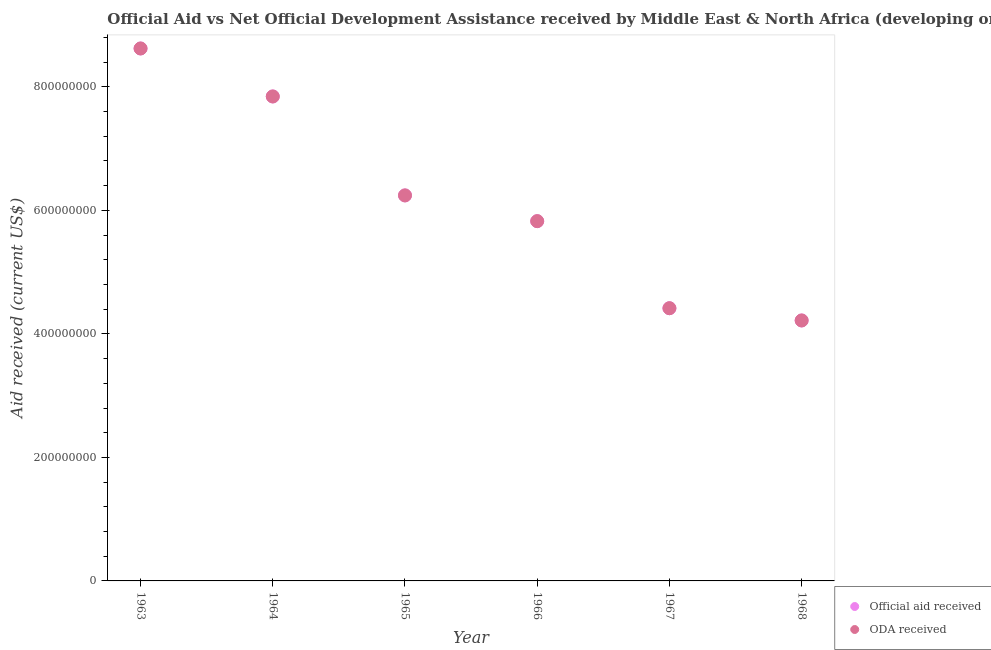How many different coloured dotlines are there?
Give a very brief answer. 2. What is the official aid received in 1964?
Make the answer very short. 7.84e+08. Across all years, what is the maximum oda received?
Offer a terse response. 8.62e+08. Across all years, what is the minimum oda received?
Make the answer very short. 4.22e+08. In which year was the oda received minimum?
Your response must be concise. 1968. What is the total oda received in the graph?
Offer a terse response. 3.72e+09. What is the difference between the oda received in 1965 and that in 1968?
Give a very brief answer. 2.02e+08. What is the difference between the official aid received in 1966 and the oda received in 1965?
Offer a very short reply. -4.17e+07. What is the average official aid received per year?
Give a very brief answer. 6.19e+08. What is the ratio of the official aid received in 1963 to that in 1964?
Keep it short and to the point. 1.1. Is the official aid received in 1966 less than that in 1967?
Give a very brief answer. No. What is the difference between the highest and the second highest official aid received?
Your answer should be very brief. 7.77e+07. What is the difference between the highest and the lowest official aid received?
Keep it short and to the point. 4.40e+08. How many years are there in the graph?
Offer a very short reply. 6. What is the difference between two consecutive major ticks on the Y-axis?
Provide a succinct answer. 2.00e+08. Are the values on the major ticks of Y-axis written in scientific E-notation?
Give a very brief answer. No. Does the graph contain any zero values?
Make the answer very short. No. How are the legend labels stacked?
Offer a terse response. Vertical. What is the title of the graph?
Provide a short and direct response. Official Aid vs Net Official Development Assistance received by Middle East & North Africa (developing only) . Does "Passenger Transport Items" appear as one of the legend labels in the graph?
Keep it short and to the point. No. What is the label or title of the Y-axis?
Your response must be concise. Aid received (current US$). What is the Aid received (current US$) of Official aid received in 1963?
Ensure brevity in your answer.  8.62e+08. What is the Aid received (current US$) in ODA received in 1963?
Ensure brevity in your answer.  8.62e+08. What is the Aid received (current US$) in Official aid received in 1964?
Your answer should be compact. 7.84e+08. What is the Aid received (current US$) of ODA received in 1964?
Make the answer very short. 7.84e+08. What is the Aid received (current US$) in Official aid received in 1965?
Offer a very short reply. 6.24e+08. What is the Aid received (current US$) in ODA received in 1965?
Give a very brief answer. 6.24e+08. What is the Aid received (current US$) in Official aid received in 1966?
Your response must be concise. 5.83e+08. What is the Aid received (current US$) in ODA received in 1966?
Provide a short and direct response. 5.83e+08. What is the Aid received (current US$) of Official aid received in 1967?
Keep it short and to the point. 4.42e+08. What is the Aid received (current US$) in ODA received in 1967?
Make the answer very short. 4.42e+08. What is the Aid received (current US$) in Official aid received in 1968?
Your answer should be compact. 4.22e+08. What is the Aid received (current US$) in ODA received in 1968?
Offer a terse response. 4.22e+08. Across all years, what is the maximum Aid received (current US$) of Official aid received?
Your answer should be compact. 8.62e+08. Across all years, what is the maximum Aid received (current US$) in ODA received?
Provide a short and direct response. 8.62e+08. Across all years, what is the minimum Aid received (current US$) in Official aid received?
Offer a terse response. 4.22e+08. Across all years, what is the minimum Aid received (current US$) in ODA received?
Offer a very short reply. 4.22e+08. What is the total Aid received (current US$) in Official aid received in the graph?
Ensure brevity in your answer.  3.72e+09. What is the total Aid received (current US$) of ODA received in the graph?
Keep it short and to the point. 3.72e+09. What is the difference between the Aid received (current US$) of Official aid received in 1963 and that in 1964?
Make the answer very short. 7.77e+07. What is the difference between the Aid received (current US$) of ODA received in 1963 and that in 1964?
Ensure brevity in your answer.  7.77e+07. What is the difference between the Aid received (current US$) of Official aid received in 1963 and that in 1965?
Offer a very short reply. 2.38e+08. What is the difference between the Aid received (current US$) in ODA received in 1963 and that in 1965?
Offer a very short reply. 2.38e+08. What is the difference between the Aid received (current US$) in Official aid received in 1963 and that in 1966?
Ensure brevity in your answer.  2.80e+08. What is the difference between the Aid received (current US$) of ODA received in 1963 and that in 1966?
Your answer should be very brief. 2.80e+08. What is the difference between the Aid received (current US$) of Official aid received in 1963 and that in 1967?
Provide a succinct answer. 4.21e+08. What is the difference between the Aid received (current US$) in ODA received in 1963 and that in 1967?
Provide a short and direct response. 4.21e+08. What is the difference between the Aid received (current US$) of Official aid received in 1963 and that in 1968?
Give a very brief answer. 4.40e+08. What is the difference between the Aid received (current US$) in ODA received in 1963 and that in 1968?
Keep it short and to the point. 4.40e+08. What is the difference between the Aid received (current US$) of Official aid received in 1964 and that in 1965?
Your answer should be very brief. 1.60e+08. What is the difference between the Aid received (current US$) of ODA received in 1964 and that in 1965?
Your answer should be very brief. 1.60e+08. What is the difference between the Aid received (current US$) of Official aid received in 1964 and that in 1966?
Your answer should be very brief. 2.02e+08. What is the difference between the Aid received (current US$) of ODA received in 1964 and that in 1966?
Offer a very short reply. 2.02e+08. What is the difference between the Aid received (current US$) of Official aid received in 1964 and that in 1967?
Your answer should be compact. 3.43e+08. What is the difference between the Aid received (current US$) of ODA received in 1964 and that in 1967?
Your answer should be very brief. 3.43e+08. What is the difference between the Aid received (current US$) of Official aid received in 1964 and that in 1968?
Offer a very short reply. 3.63e+08. What is the difference between the Aid received (current US$) of ODA received in 1964 and that in 1968?
Your answer should be compact. 3.63e+08. What is the difference between the Aid received (current US$) of Official aid received in 1965 and that in 1966?
Offer a terse response. 4.17e+07. What is the difference between the Aid received (current US$) of ODA received in 1965 and that in 1966?
Provide a short and direct response. 4.17e+07. What is the difference between the Aid received (current US$) in Official aid received in 1965 and that in 1967?
Your answer should be compact. 1.83e+08. What is the difference between the Aid received (current US$) of ODA received in 1965 and that in 1967?
Offer a terse response. 1.83e+08. What is the difference between the Aid received (current US$) in Official aid received in 1965 and that in 1968?
Your response must be concise. 2.02e+08. What is the difference between the Aid received (current US$) of ODA received in 1965 and that in 1968?
Provide a short and direct response. 2.02e+08. What is the difference between the Aid received (current US$) in Official aid received in 1966 and that in 1967?
Provide a succinct answer. 1.41e+08. What is the difference between the Aid received (current US$) of ODA received in 1966 and that in 1967?
Offer a terse response. 1.41e+08. What is the difference between the Aid received (current US$) in Official aid received in 1966 and that in 1968?
Offer a terse response. 1.61e+08. What is the difference between the Aid received (current US$) of ODA received in 1966 and that in 1968?
Your answer should be very brief. 1.61e+08. What is the difference between the Aid received (current US$) in Official aid received in 1967 and that in 1968?
Provide a succinct answer. 1.98e+07. What is the difference between the Aid received (current US$) in ODA received in 1967 and that in 1968?
Provide a short and direct response. 1.98e+07. What is the difference between the Aid received (current US$) of Official aid received in 1963 and the Aid received (current US$) of ODA received in 1964?
Offer a terse response. 7.77e+07. What is the difference between the Aid received (current US$) in Official aid received in 1963 and the Aid received (current US$) in ODA received in 1965?
Offer a terse response. 2.38e+08. What is the difference between the Aid received (current US$) in Official aid received in 1963 and the Aid received (current US$) in ODA received in 1966?
Ensure brevity in your answer.  2.80e+08. What is the difference between the Aid received (current US$) of Official aid received in 1963 and the Aid received (current US$) of ODA received in 1967?
Ensure brevity in your answer.  4.21e+08. What is the difference between the Aid received (current US$) of Official aid received in 1963 and the Aid received (current US$) of ODA received in 1968?
Provide a succinct answer. 4.40e+08. What is the difference between the Aid received (current US$) in Official aid received in 1964 and the Aid received (current US$) in ODA received in 1965?
Give a very brief answer. 1.60e+08. What is the difference between the Aid received (current US$) in Official aid received in 1964 and the Aid received (current US$) in ODA received in 1966?
Give a very brief answer. 2.02e+08. What is the difference between the Aid received (current US$) in Official aid received in 1964 and the Aid received (current US$) in ODA received in 1967?
Your answer should be compact. 3.43e+08. What is the difference between the Aid received (current US$) in Official aid received in 1964 and the Aid received (current US$) in ODA received in 1968?
Make the answer very short. 3.63e+08. What is the difference between the Aid received (current US$) of Official aid received in 1965 and the Aid received (current US$) of ODA received in 1966?
Provide a succinct answer. 4.17e+07. What is the difference between the Aid received (current US$) of Official aid received in 1965 and the Aid received (current US$) of ODA received in 1967?
Your response must be concise. 1.83e+08. What is the difference between the Aid received (current US$) in Official aid received in 1965 and the Aid received (current US$) in ODA received in 1968?
Your answer should be very brief. 2.02e+08. What is the difference between the Aid received (current US$) in Official aid received in 1966 and the Aid received (current US$) in ODA received in 1967?
Your answer should be very brief. 1.41e+08. What is the difference between the Aid received (current US$) in Official aid received in 1966 and the Aid received (current US$) in ODA received in 1968?
Provide a succinct answer. 1.61e+08. What is the difference between the Aid received (current US$) in Official aid received in 1967 and the Aid received (current US$) in ODA received in 1968?
Your answer should be compact. 1.98e+07. What is the average Aid received (current US$) of Official aid received per year?
Your response must be concise. 6.19e+08. What is the average Aid received (current US$) of ODA received per year?
Give a very brief answer. 6.19e+08. In the year 1964, what is the difference between the Aid received (current US$) of Official aid received and Aid received (current US$) of ODA received?
Give a very brief answer. 0. In the year 1966, what is the difference between the Aid received (current US$) of Official aid received and Aid received (current US$) of ODA received?
Provide a succinct answer. 0. In the year 1968, what is the difference between the Aid received (current US$) of Official aid received and Aid received (current US$) of ODA received?
Make the answer very short. 0. What is the ratio of the Aid received (current US$) in Official aid received in 1963 to that in 1964?
Your response must be concise. 1.1. What is the ratio of the Aid received (current US$) of ODA received in 1963 to that in 1964?
Give a very brief answer. 1.1. What is the ratio of the Aid received (current US$) of Official aid received in 1963 to that in 1965?
Your answer should be very brief. 1.38. What is the ratio of the Aid received (current US$) in ODA received in 1963 to that in 1965?
Keep it short and to the point. 1.38. What is the ratio of the Aid received (current US$) in Official aid received in 1963 to that in 1966?
Provide a succinct answer. 1.48. What is the ratio of the Aid received (current US$) of ODA received in 1963 to that in 1966?
Keep it short and to the point. 1.48. What is the ratio of the Aid received (current US$) in Official aid received in 1963 to that in 1967?
Give a very brief answer. 1.95. What is the ratio of the Aid received (current US$) of ODA received in 1963 to that in 1967?
Keep it short and to the point. 1.95. What is the ratio of the Aid received (current US$) of Official aid received in 1963 to that in 1968?
Offer a very short reply. 2.04. What is the ratio of the Aid received (current US$) of ODA received in 1963 to that in 1968?
Offer a very short reply. 2.04. What is the ratio of the Aid received (current US$) in Official aid received in 1964 to that in 1965?
Ensure brevity in your answer.  1.26. What is the ratio of the Aid received (current US$) in ODA received in 1964 to that in 1965?
Provide a short and direct response. 1.26. What is the ratio of the Aid received (current US$) in Official aid received in 1964 to that in 1966?
Your answer should be compact. 1.35. What is the ratio of the Aid received (current US$) in ODA received in 1964 to that in 1966?
Offer a terse response. 1.35. What is the ratio of the Aid received (current US$) of Official aid received in 1964 to that in 1967?
Make the answer very short. 1.78. What is the ratio of the Aid received (current US$) of ODA received in 1964 to that in 1967?
Give a very brief answer. 1.78. What is the ratio of the Aid received (current US$) of Official aid received in 1964 to that in 1968?
Your answer should be very brief. 1.86. What is the ratio of the Aid received (current US$) in ODA received in 1964 to that in 1968?
Ensure brevity in your answer.  1.86. What is the ratio of the Aid received (current US$) of Official aid received in 1965 to that in 1966?
Make the answer very short. 1.07. What is the ratio of the Aid received (current US$) in ODA received in 1965 to that in 1966?
Offer a terse response. 1.07. What is the ratio of the Aid received (current US$) of Official aid received in 1965 to that in 1967?
Make the answer very short. 1.41. What is the ratio of the Aid received (current US$) in ODA received in 1965 to that in 1967?
Your answer should be compact. 1.41. What is the ratio of the Aid received (current US$) of Official aid received in 1965 to that in 1968?
Give a very brief answer. 1.48. What is the ratio of the Aid received (current US$) of ODA received in 1965 to that in 1968?
Offer a very short reply. 1.48. What is the ratio of the Aid received (current US$) of Official aid received in 1966 to that in 1967?
Your response must be concise. 1.32. What is the ratio of the Aid received (current US$) of ODA received in 1966 to that in 1967?
Keep it short and to the point. 1.32. What is the ratio of the Aid received (current US$) of Official aid received in 1966 to that in 1968?
Your answer should be compact. 1.38. What is the ratio of the Aid received (current US$) in ODA received in 1966 to that in 1968?
Keep it short and to the point. 1.38. What is the ratio of the Aid received (current US$) of Official aid received in 1967 to that in 1968?
Your answer should be very brief. 1.05. What is the ratio of the Aid received (current US$) of ODA received in 1967 to that in 1968?
Your answer should be very brief. 1.05. What is the difference between the highest and the second highest Aid received (current US$) in Official aid received?
Ensure brevity in your answer.  7.77e+07. What is the difference between the highest and the second highest Aid received (current US$) in ODA received?
Your response must be concise. 7.77e+07. What is the difference between the highest and the lowest Aid received (current US$) in Official aid received?
Offer a terse response. 4.40e+08. What is the difference between the highest and the lowest Aid received (current US$) of ODA received?
Make the answer very short. 4.40e+08. 